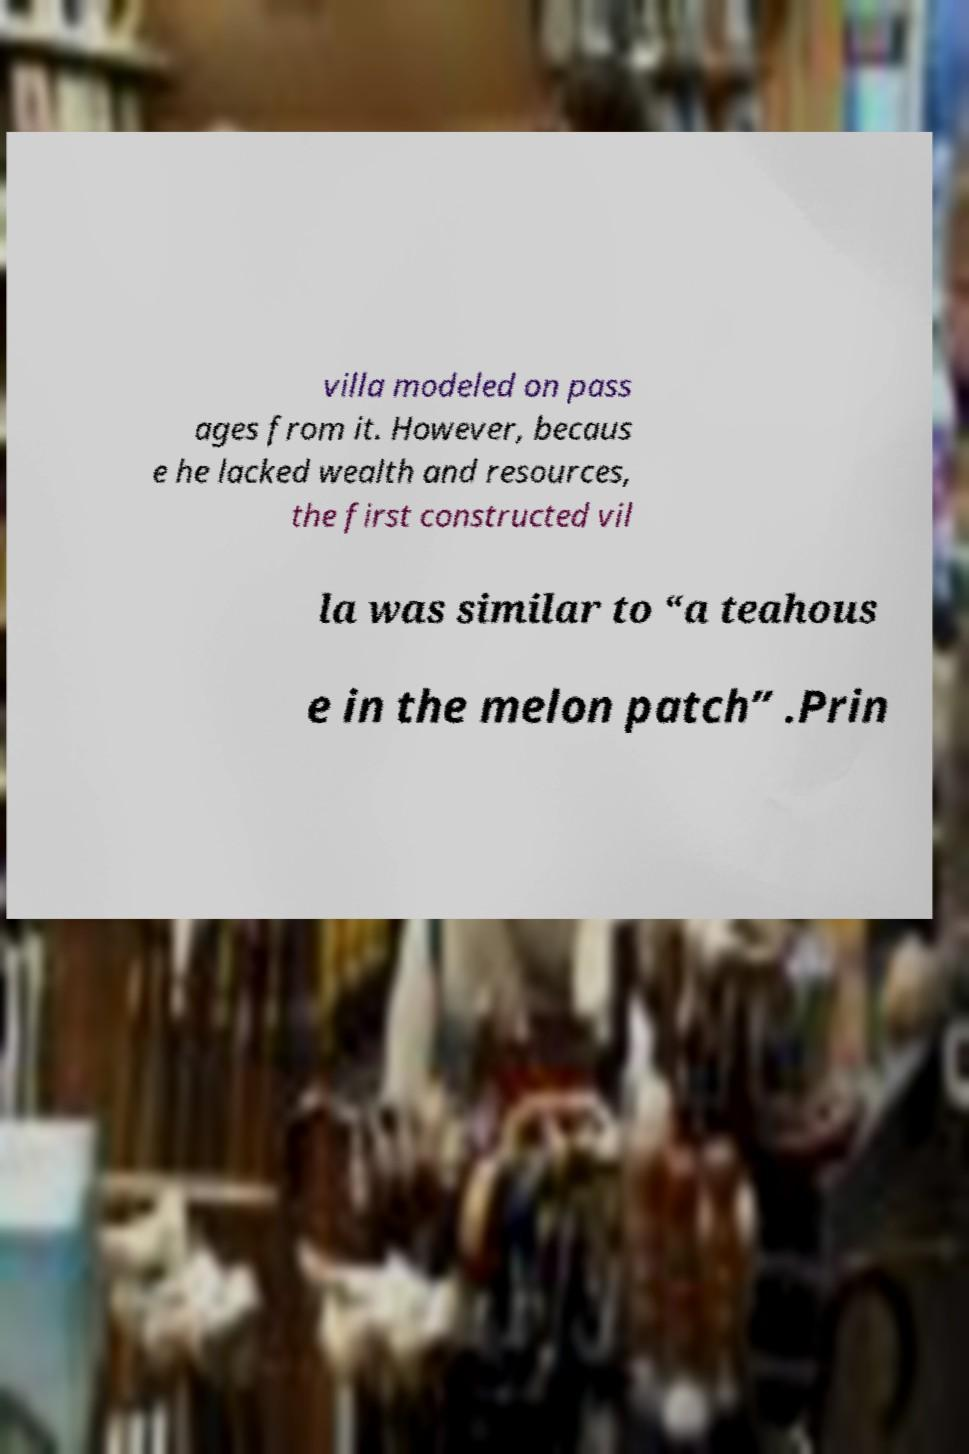Could you extract and type out the text from this image? villa modeled on pass ages from it. However, becaus e he lacked wealth and resources, the first constructed vil la was similar to “a teahous e in the melon patch” .Prin 